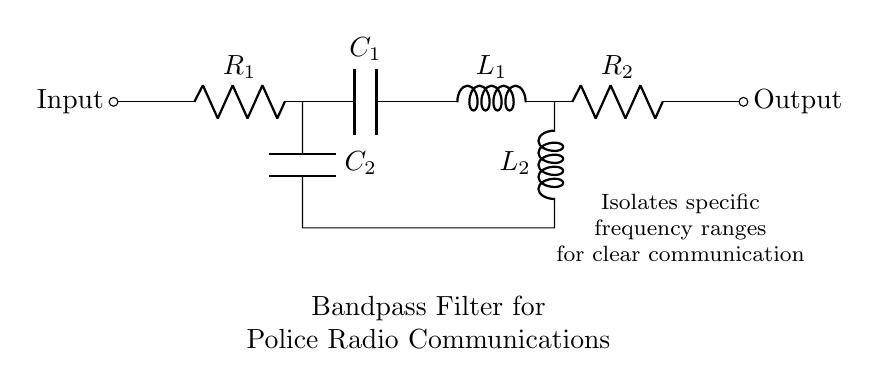What is the function of this circuit? The circuit is designed as a bandpass filter, which allows a specific range of frequencies to pass while attenuating others. This is evident from its design, which includes both inductive and capacitive components that selectively influence the frequency response.
Answer: Bandpass filter How many resistors are in the circuit? There are two resistors labeled as R1 and R2 in the circuit diagram. Each is indicated clearly in the drawing, contributing to the overall functionality of the bandpass filter.
Answer: 2 What components are used to create the bandpass characteristics? The bandpass characteristics are achieved by the combination of inductors (L1 and L2) and capacitors (C1 and C2). These components work together to define the passband of the filter in accordance with the circuit's design principle.
Answer: Inductors and capacitors What is at the input of the circuit? The input of the circuit is a short connection that indicates where the signal enters the bandpass filter. It is essentially the point where the incoming radio signal is introduced for filtering.
Answer: Input What is the purpose of capacitors C1 and C2? Capacitors C1 and C2 are used to allow specific frequency ranges to pass through while blocking others. Their placement in the circuit influences the cut-off frequencies, effectively setting the bandwidth of the filter.
Answer: Allow specific frequencies How do resistors R1 and R2 impact the circuit's performance? Resistors R1 and R2 play a crucial role in controlling the impedance and damping in the circuit. They affect the overall voltage and current distribution, thereby influencing the cutoff frequencies and the sharpness of the filter response.
Answer: Control impedance and damping What kind of signal does this circuit isolate? This circuit is designed to isolate specific frequency ranges useful for clear communication, particularly those used in police radio communications. This is indicative of its practical application in real-world communication systems.
Answer: Police radio frequencies 